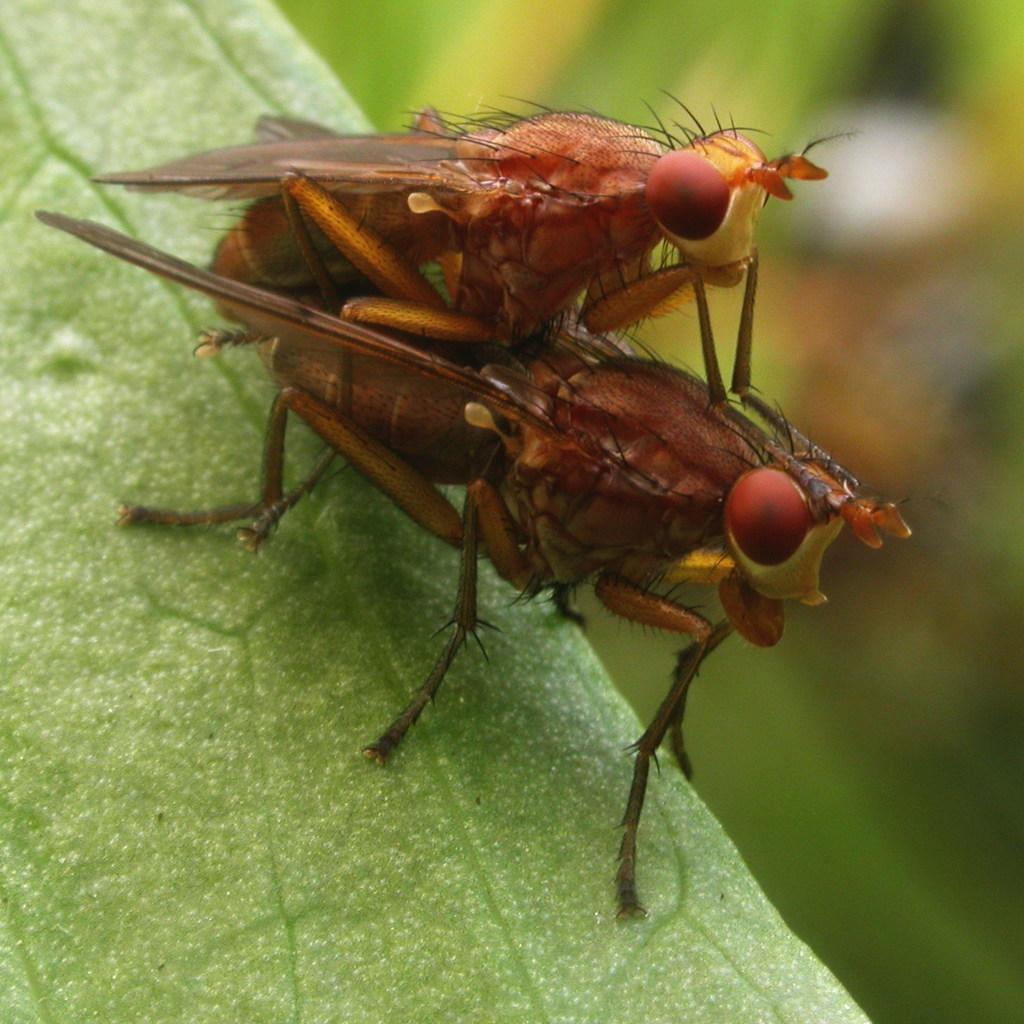What type of living organisms can be seen on the plant in the image? There are insects on a plant in the image. What type of sound can be heard coming from the whistle in the image? There is no whistle present in the image, so it's not possible to determine what sound might be heard. 